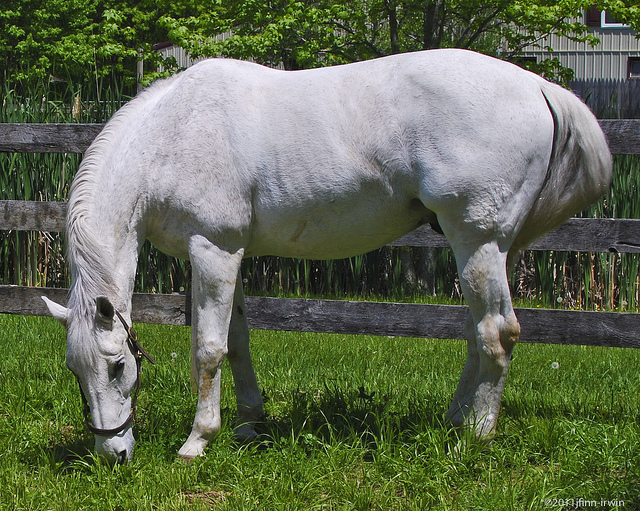How many horses can you see in the image? I can see only one horse in the image. 